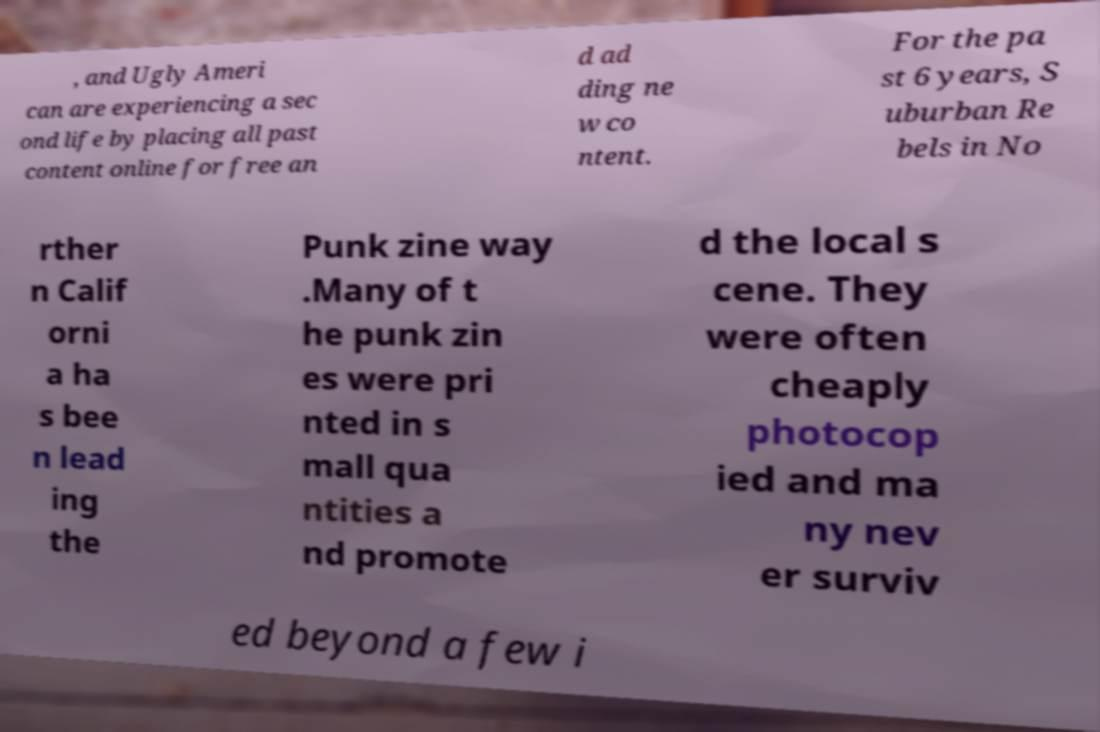I need the written content from this picture converted into text. Can you do that? , and Ugly Ameri can are experiencing a sec ond life by placing all past content online for free an d ad ding ne w co ntent. For the pa st 6 years, S uburban Re bels in No rther n Calif orni a ha s bee n lead ing the Punk zine way .Many of t he punk zin es were pri nted in s mall qua ntities a nd promote d the local s cene. They were often cheaply photocop ied and ma ny nev er surviv ed beyond a few i 